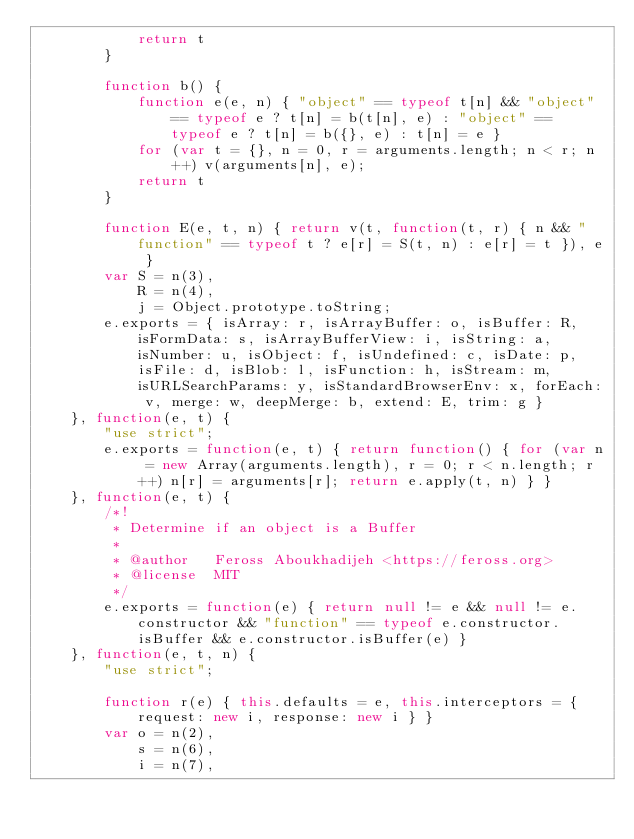<code> <loc_0><loc_0><loc_500><loc_500><_JavaScript_>            return t
        }

        function b() {
            function e(e, n) { "object" == typeof t[n] && "object" == typeof e ? t[n] = b(t[n], e) : "object" == typeof e ? t[n] = b({}, e) : t[n] = e }
            for (var t = {}, n = 0, r = arguments.length; n < r; n++) v(arguments[n], e);
            return t
        }

        function E(e, t, n) { return v(t, function(t, r) { n && "function" == typeof t ? e[r] = S(t, n) : e[r] = t }), e }
        var S = n(3),
            R = n(4),
            j = Object.prototype.toString;
        e.exports = { isArray: r, isArrayBuffer: o, isBuffer: R, isFormData: s, isArrayBufferView: i, isString: a, isNumber: u, isObject: f, isUndefined: c, isDate: p, isFile: d, isBlob: l, isFunction: h, isStream: m, isURLSearchParams: y, isStandardBrowserEnv: x, forEach: v, merge: w, deepMerge: b, extend: E, trim: g }
    }, function(e, t) {
        "use strict";
        e.exports = function(e, t) { return function() { for (var n = new Array(arguments.length), r = 0; r < n.length; r++) n[r] = arguments[r]; return e.apply(t, n) } }
    }, function(e, t) {
        /*!
         * Determine if an object is a Buffer
         *
         * @author   Feross Aboukhadijeh <https://feross.org>
         * @license  MIT
         */
        e.exports = function(e) { return null != e && null != e.constructor && "function" == typeof e.constructor.isBuffer && e.constructor.isBuffer(e) }
    }, function(e, t, n) {
        "use strict";

        function r(e) { this.defaults = e, this.interceptors = { request: new i, response: new i } }
        var o = n(2),
            s = n(6),
            i = n(7),</code> 